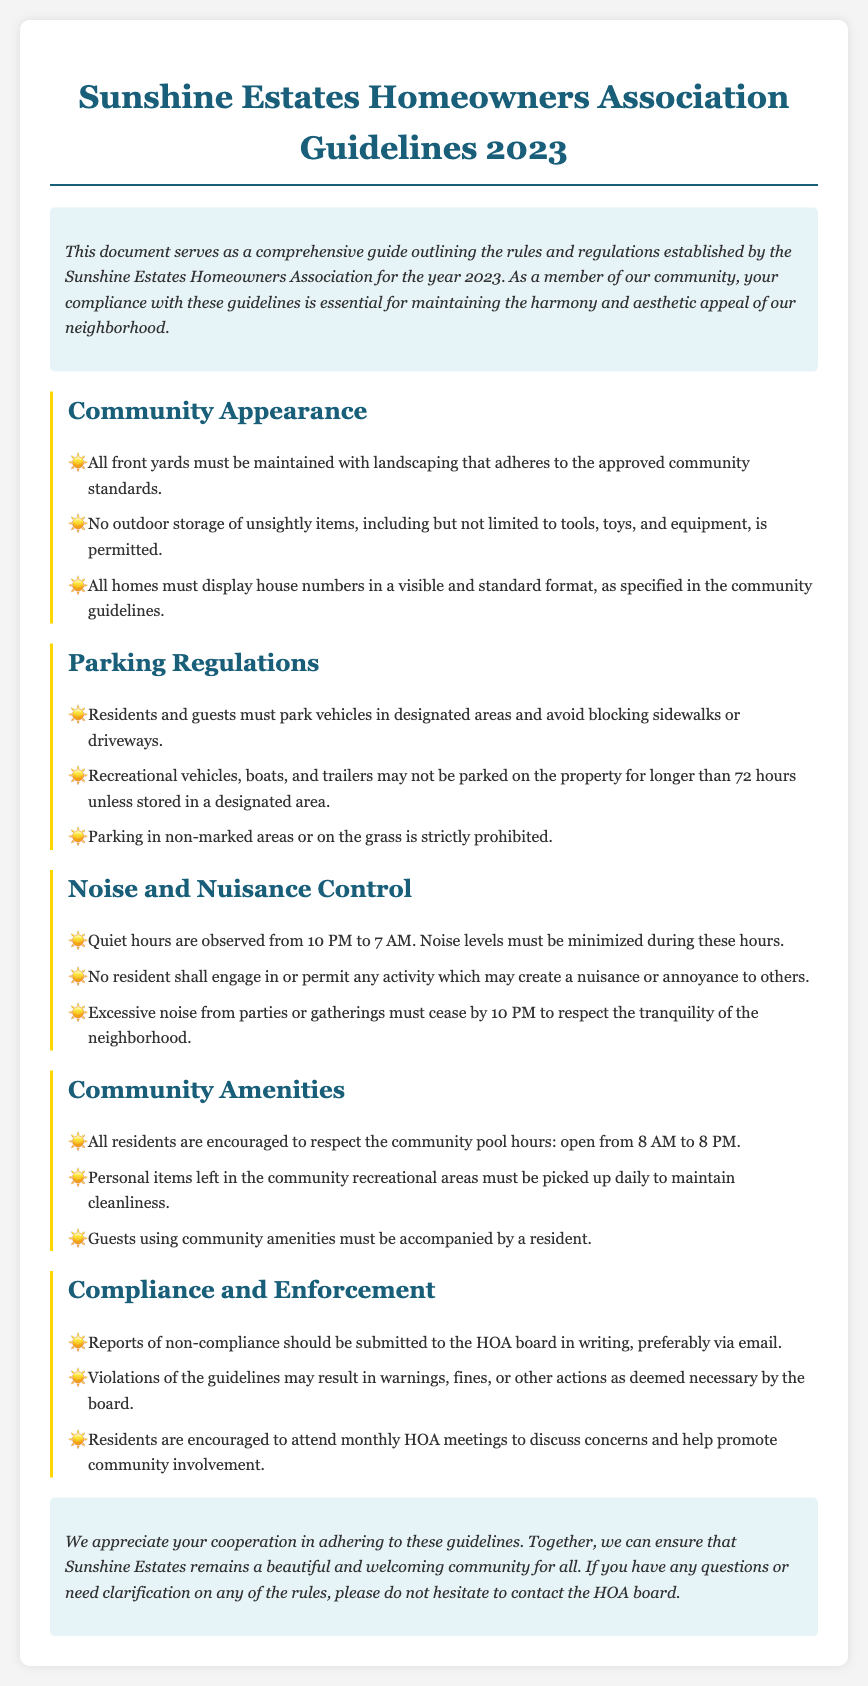What year do these guidelines apply to? The document specifically states the guidelines are for the year 2023.
Answer: 2023 What are the community pool hours? The guidelines mention that the community pool is open from 8 AM to 8 PM.
Answer: 8 AM to 8 PM How long can recreational vehicles be parked on the property? The guidelines state that recreational vehicles may not be parked for longer than 72 hours unless stored in a designated area.
Answer: 72 hours What must residents do with personal items left in community recreational areas? The guidelines specify that personal items must be picked up daily to maintain cleanliness.
Answer: Picked up daily When are the quiet hours observed? The document indicates quiet hours are from 10 PM to 7 AM.
Answer: 10 PM to 7 AM What should residents do if they report a non-compliance issue? The guidelines suggest that reports should be submitted in writing, preferably via email.
Answer: In writing, preferably via email What is the consequence for violating the guidelines? The document states that violations may result in warnings, fines, or other actions as deemed necessary by the board.
Answer: Warnings, fines, or other actions How must house numbers be displayed? The guidelines specify that all homes must display house numbers in a visible and standard format.
Answer: Visible and standard format What is prohibited on outdoor storage? The document lists that storage of unsightly items, including tools, toys, and equipment, is not permitted.
Answer: Unsightly items, including tools, toys, and equipment 